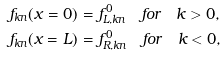<formula> <loc_0><loc_0><loc_500><loc_500>f _ { k n } ( x = 0 ) & = f ^ { 0 } _ { L , k n } \quad f o r \quad k > 0 , \\ f _ { k n } ( x = L ) & = f ^ { 0 } _ { R , k n } \quad f o r \quad k < 0 ,</formula> 